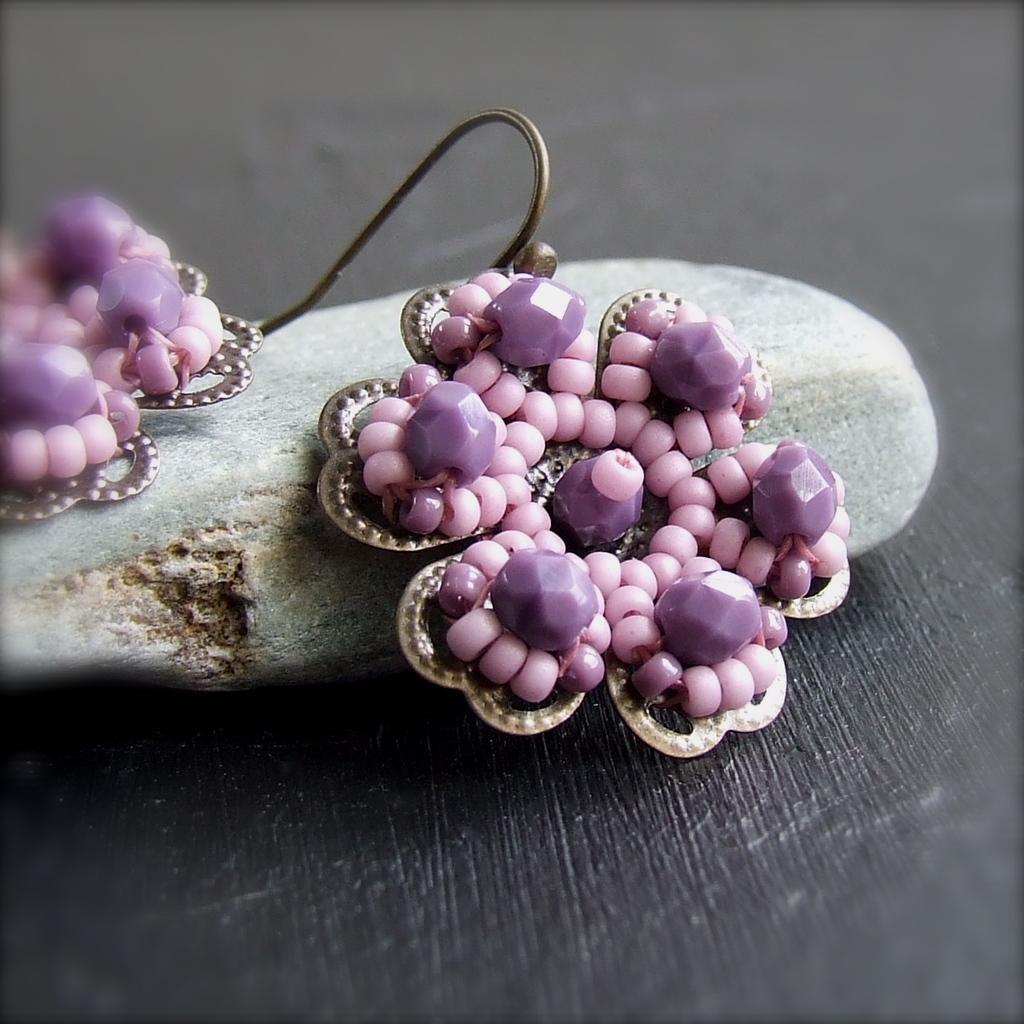Can you describe this image briefly? In this image, we can see earrings are placed on the stone. This stone is on the wooden surface. 